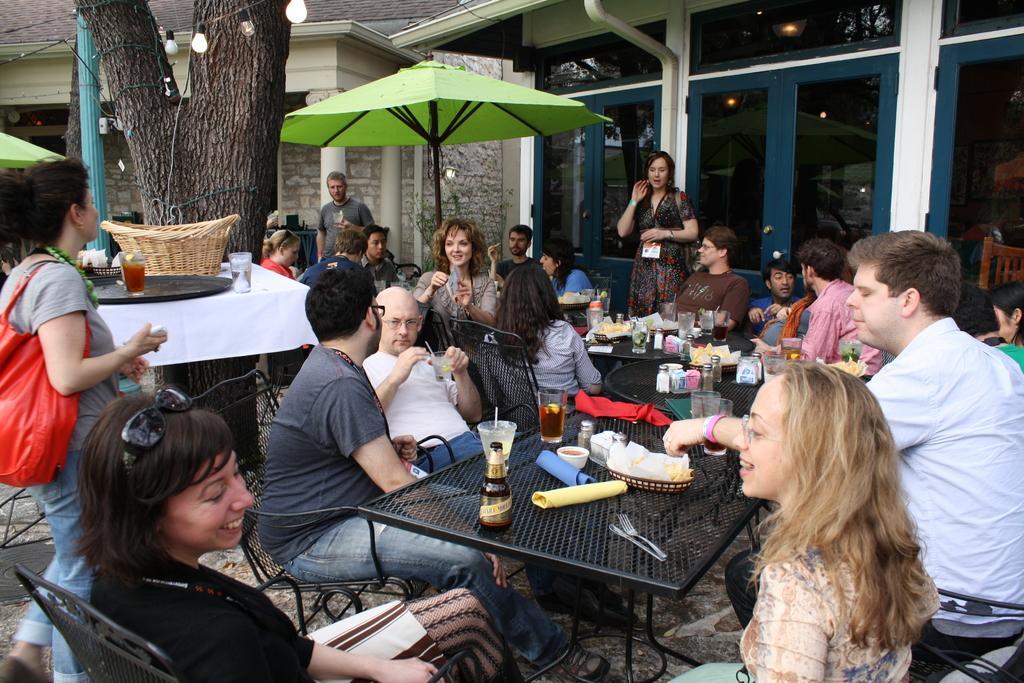In one or two sentences, can you explain what this image depicts? In this image we can see many people. Some are sitting on chairs and few are standing. Also there are tables. On the tables there are bottles, glasses, bowls, baskets, fork, knife and many other things. In the back there are umbrellas. Also there is a tree. And there are buildings with doors, windows and pillars. Also there are lights. And the lady on the left side is having a bag. 